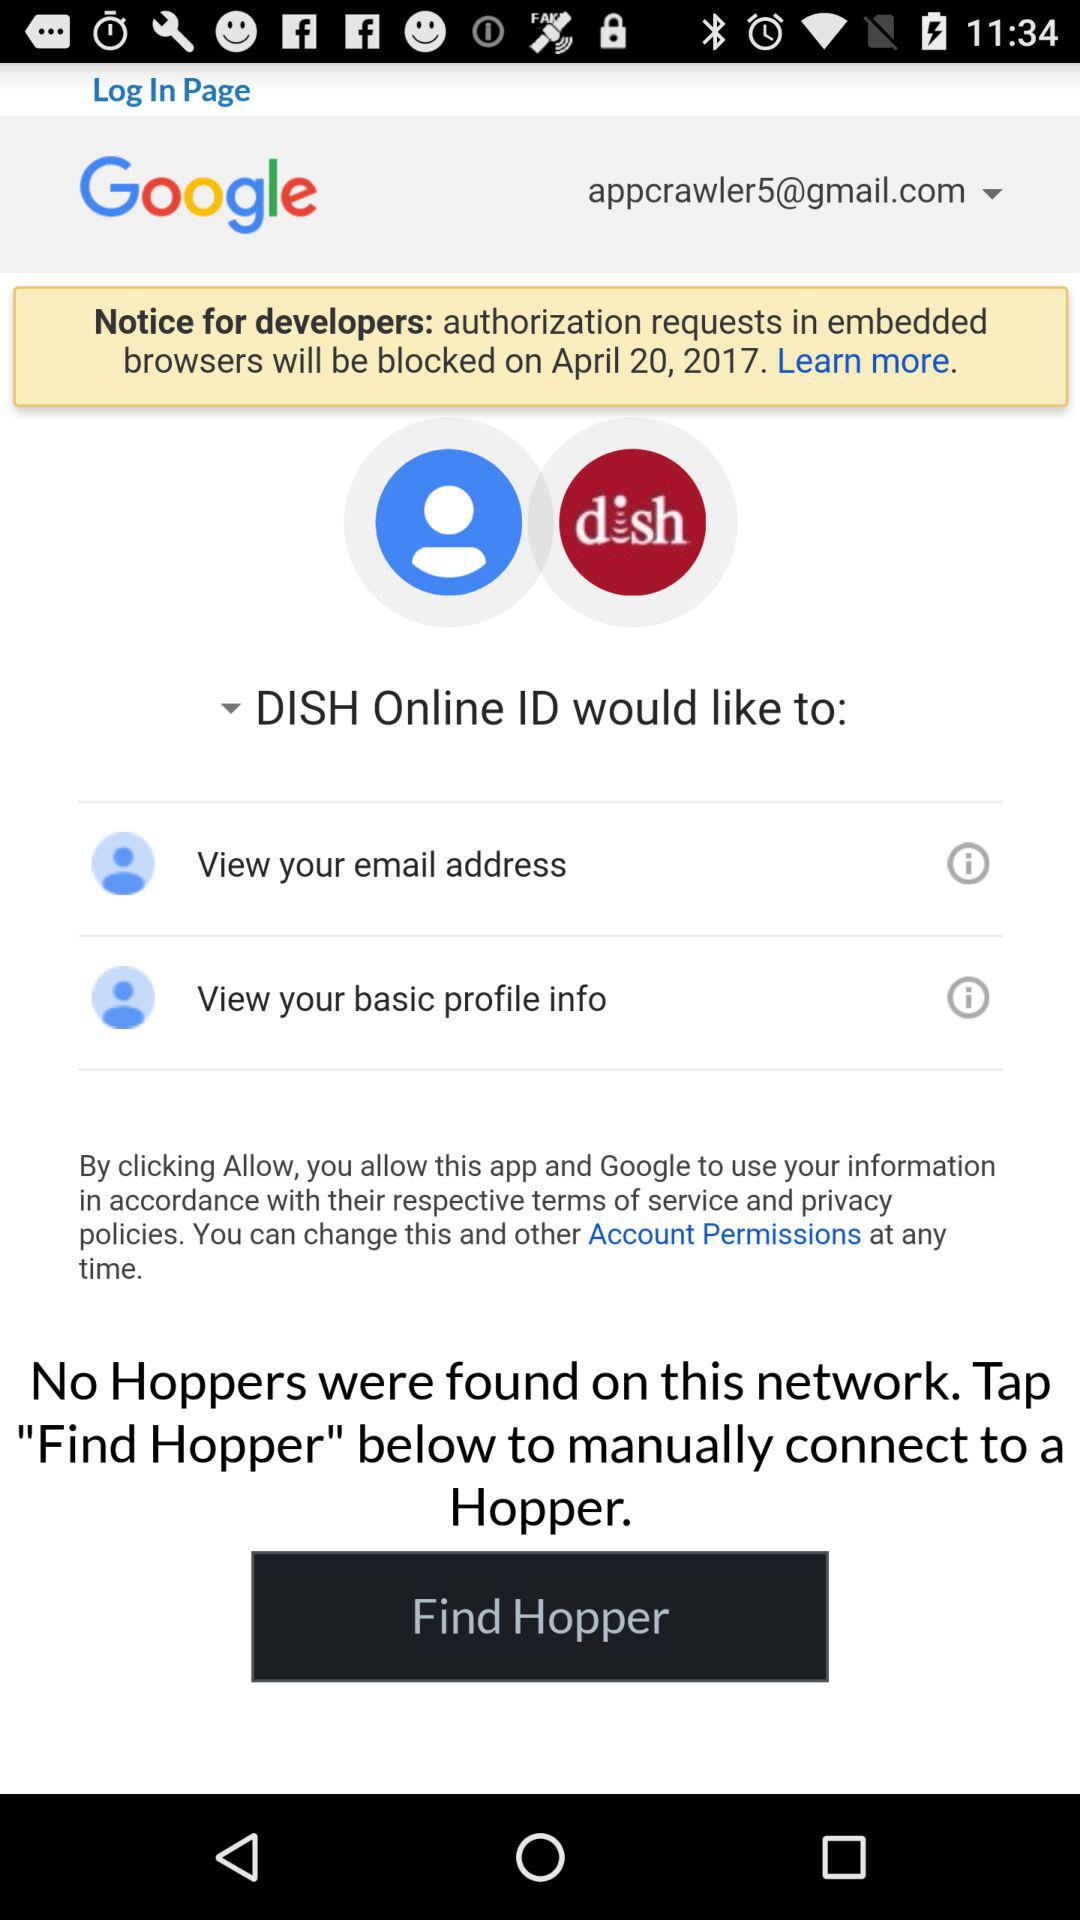What is the email address? The email address is appcrawler5@gmail.com. 